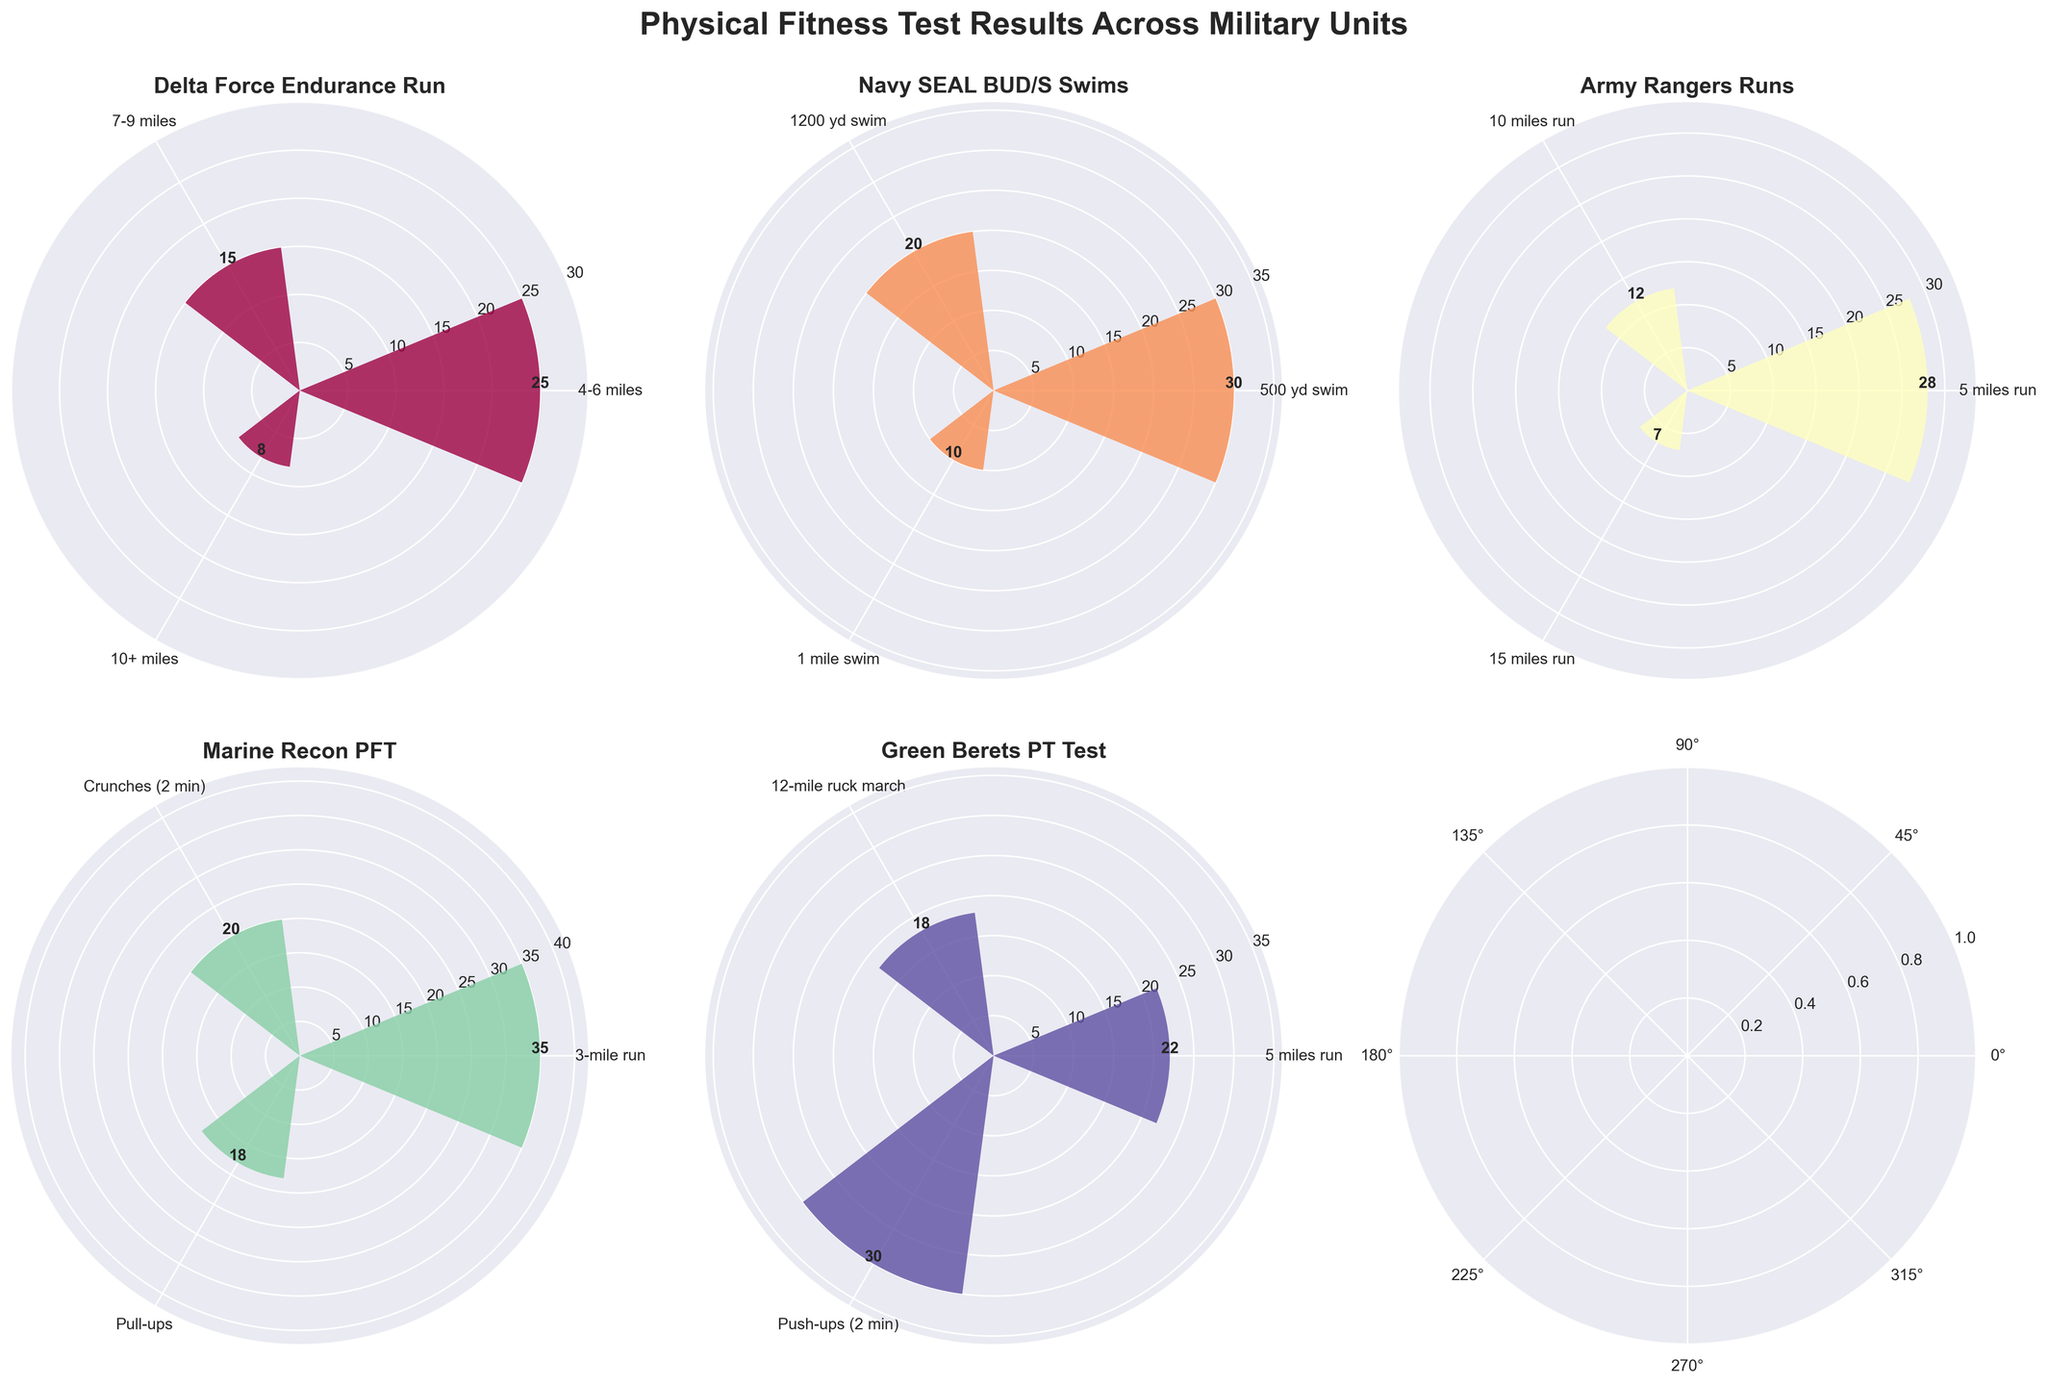what's the title of the figure? The title of the figure is usually found at the top and provides an overview of the content presented in the chart. In this case, the title reads "Physical Fitness Test Results Across Military Units".
Answer: Physical Fitness Test Results Across Military Units How many units are plotted in the figure? To determine the number of units, we count the unique titles in each subplot, which are named after different military units like Delta Force, Navy SEAL, etc.
Answer: 5 Which unit has the highest frequency for a single test result? To find the highest frequency, look for the tallest bar in each subplot and then compare across all subplots. The Marine Recon PFT's 3-mile run has the highest frequency with a value of 35.
Answer: Marine Recon PFT What is the combined total frequency for the Delta Force Endurance Run tests? Add up the frequencies for all the tests under Delta Force: 25 (4-6 miles) + 15 (7-9 miles) + 8 (10+ miles). The total is 48.
Answer: 48 Which unit has the most varied types of tests? Check each subplot to see which unit has the most different types of tests, indicated by the number of distinct bars.
Answer: Marine Recon PFT Among the Green Berets PT Test, which test has the lowest frequency? Identify the shortest bar in the Green Berets PT Test subplot. The shortest bar corresponds to the 12-mile ruck march with a frequency of 18.
Answer: 12-mile ruck march How does the frequency of the Army Rangers' 5-mile run compare to the frequency of the Green Berets' 5-mile run? Compare the bar heights for the Army Rangers' 5-mile run and the Green Berets' 5-mile run. The Army Rangers' 5-mile run has a frequency of 28, while the Green Berets' 5-mile run has a frequency of 22.
Answer: Army Rangers' 5-mile run is higher What is the average frequency of the tests for the Navy SEAL BUD/S Swims? To find the average, sum the frequencies of the Navy SEAL BUD/S Swims tests and divide by the number of tests: (30 + 20 + 10) / 3. This gives us an average of 20.
Answer: 20 Which test category has the most consistent (least variation in) frequencies for Marine Recon PFT? Look at the Marine Recon PFT subplot and compare the differences between the bars. The frequencies for the Marine Recon PFT tests are 35 (3-mile run), 20 (Crunches), and 18 (Pull-ups), with the smallest variation between Crunches and Pull-ups.
Answer: Crunches and Pull-ups If you combine the frequencies of all the tests for the Marine Recon PFT, how do they compare to the combined frequencies of the Delta Force Endurance Run tests? Calculate the total frequencies for both: Marine Recon PFT (35 + 20 + 18 = 73) and Delta Force Endurance Run (25 + 15 + 8 = 48). The Marine Recon PFT has a higher combined frequency.
Answer: Marine Recon PFT is higher 